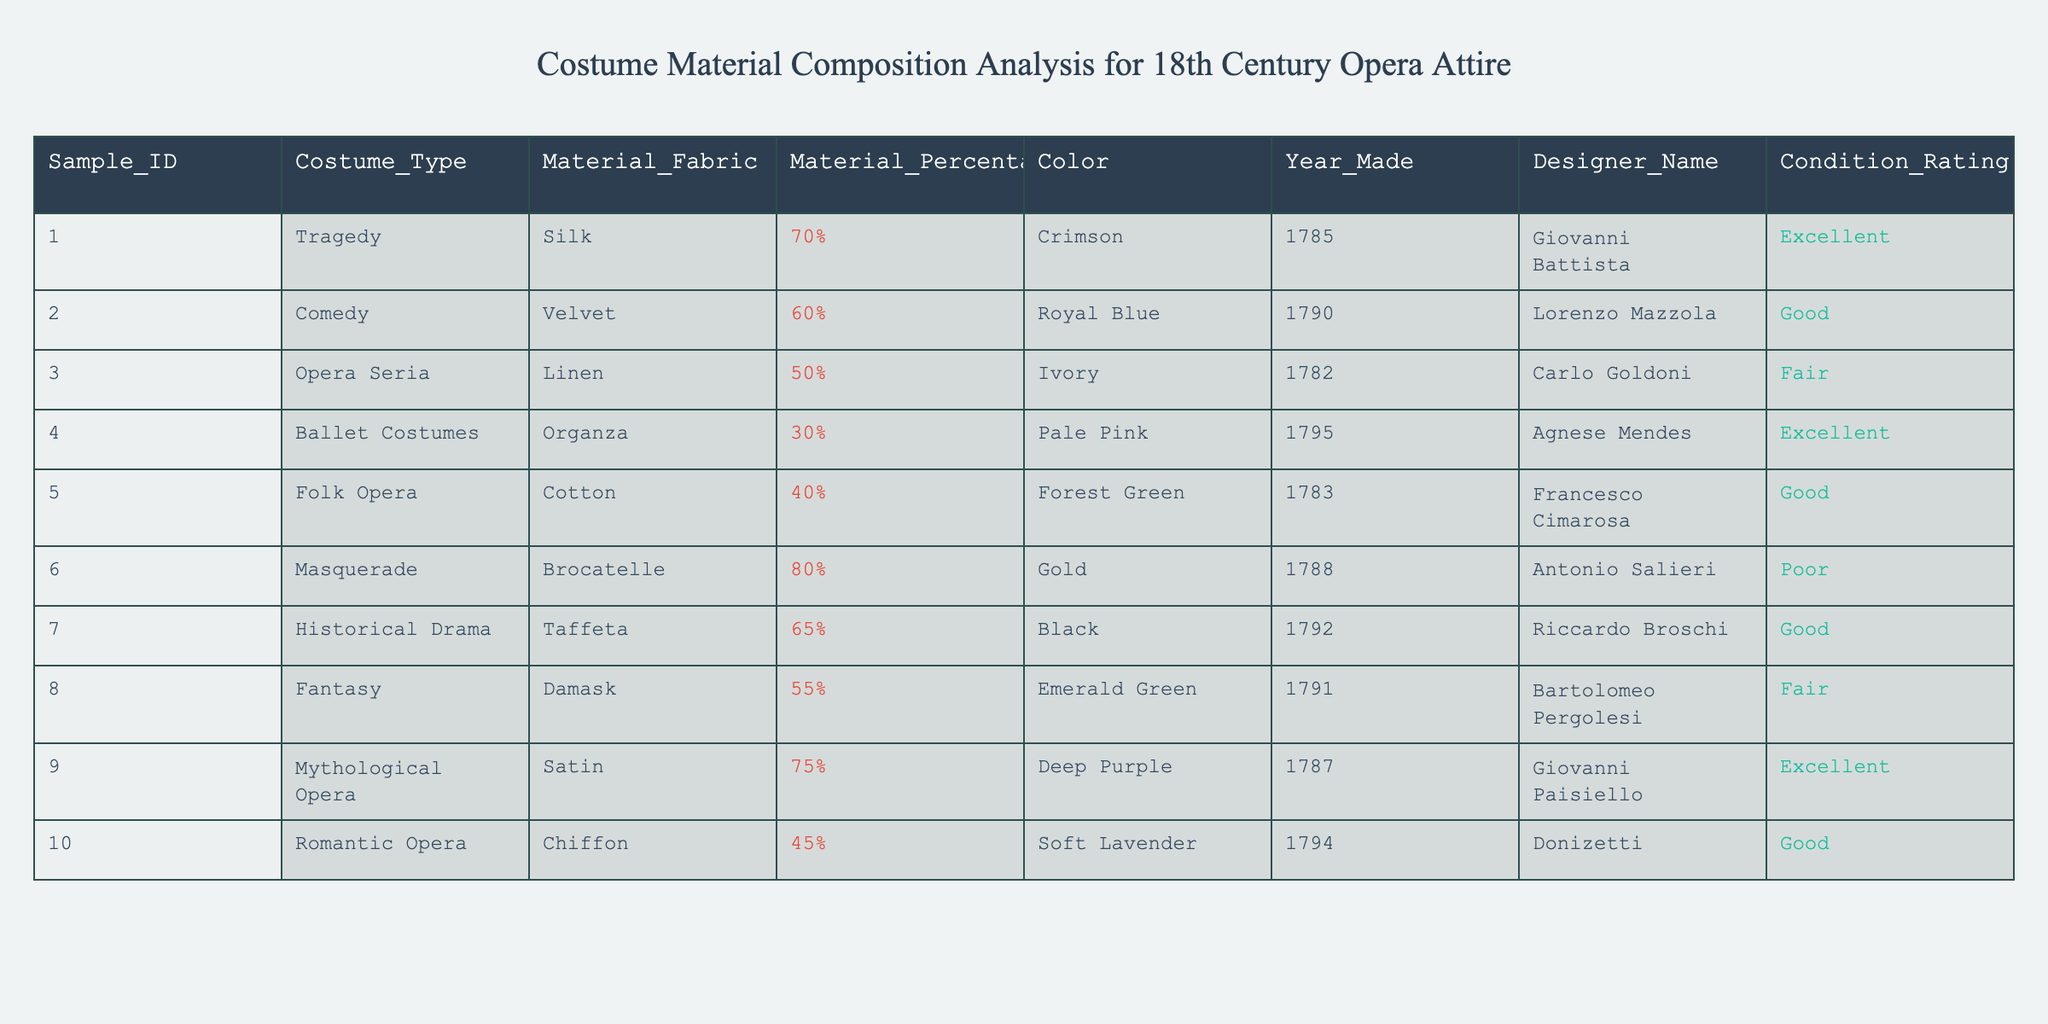What is the percentage of silk in the "Tragedy" costume? The table shows that for Sample ID 001, which corresponds to "Tragedy," the Material_Fabric is Silk and the Material_Percentage is 70%.
Answer: 70% Which costume type has the highest percentage of gold material? Looking at the entries, Sample ID 006 is for "Masquerade" and has a Material_Percentage of 80% for Brocatelle, which is described as gold. This is the highest percentage in the table.
Answer: Masquerade True or False: The "Historical Drama" costume was made in 1791. According to the table, Sample ID 007 is for "Historical Drama" and was made in 1792, not 1791, making the statement false.
Answer: False What is the average year made for all costumes listed? The years made are 1785, 1790, 1782, 1795, 1783, 1788, 1792, 1791, 1787, and 1794. There are 10 samples, and the sum of the years is 1785 + 1790 + 1782 + 1795 + 1783 + 1788 + 1792 + 1791 + 1787 + 1794 = 17888. The average is 17888/10 = 1788.8, which can be rounded to 1789.
Answer: 1789 Which costume has the worst condition rating, and what is that rating? The table indicates that Sample ID 006 ("Masquerade") has a Condition_Rating of Poor, which is the worst rating present in the table.
Answer: Masquerade, Poor How many costumes were made using velvet as the primary fabric? The table shows that Sample ID 002 ("Comedy") is the only entry with Material_Fabric listed as Velvet. Thus, there is only one such costume.
Answer: 1 Which color is associated with the "Fantasy" costume? From the information available for Sample ID 008, the Costume_Type is "Fantasy," and the associated Color is Emerald Green.
Answer: Emerald Green What is the difference in material percentage between the "Opera Seria" and "Masquerade" costumes? The "Opera Seria" (Sample ID 003) has a Material_Percentage of 50% (Linen) and the "Masquerade" (Sample ID 006) has a Material_Percentage of 80% (Brocatelle). The difference is 80% - 50% = 30%.
Answer: 30% 